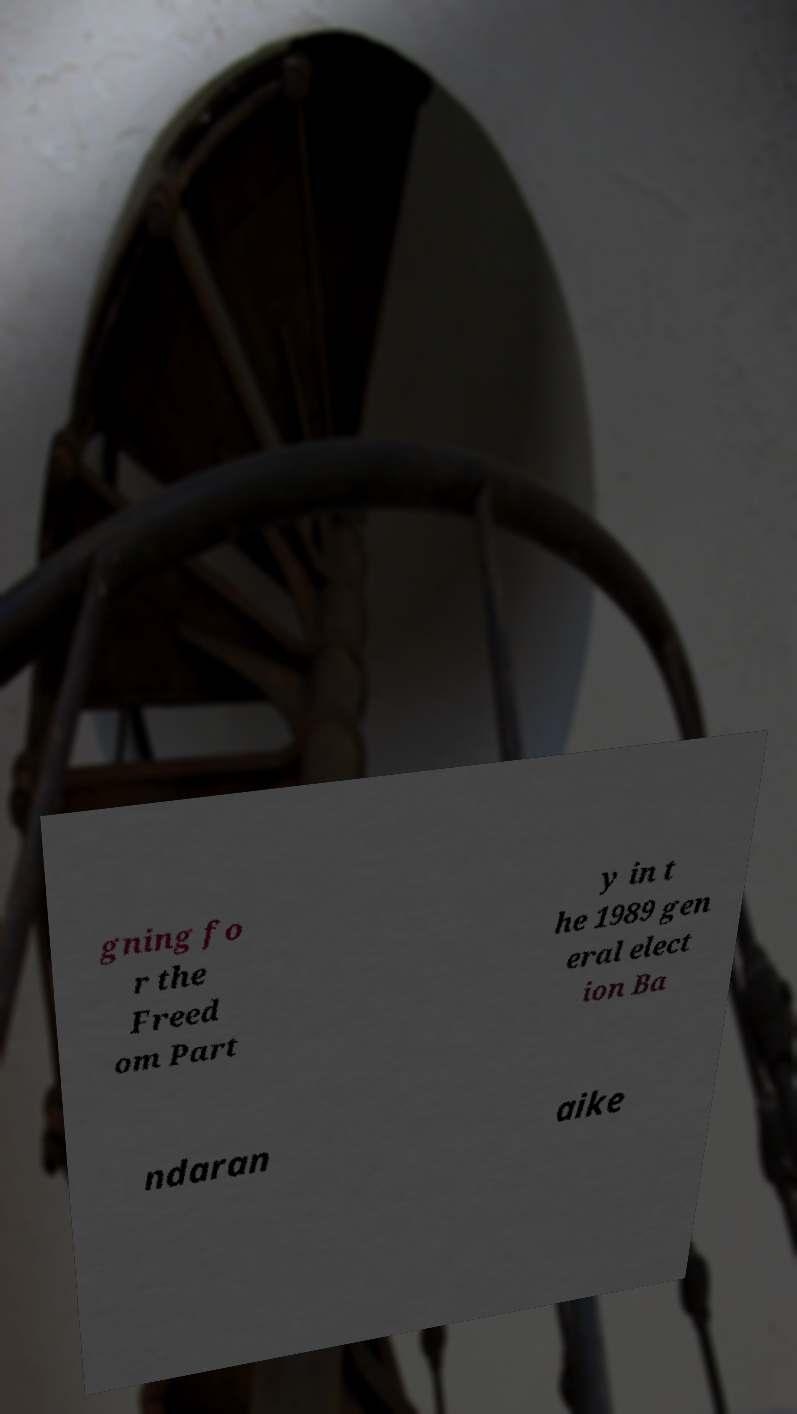There's text embedded in this image that I need extracted. Can you transcribe it verbatim? gning fo r the Freed om Part y in t he 1989 gen eral elect ion Ba ndaran aike 